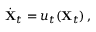<formula> <loc_0><loc_0><loc_500><loc_500>\dot { \mathbf X } _ { t } = { \boldsymbol u } _ { t } ( { \mathbf X } _ { t } ) \, ,</formula> 